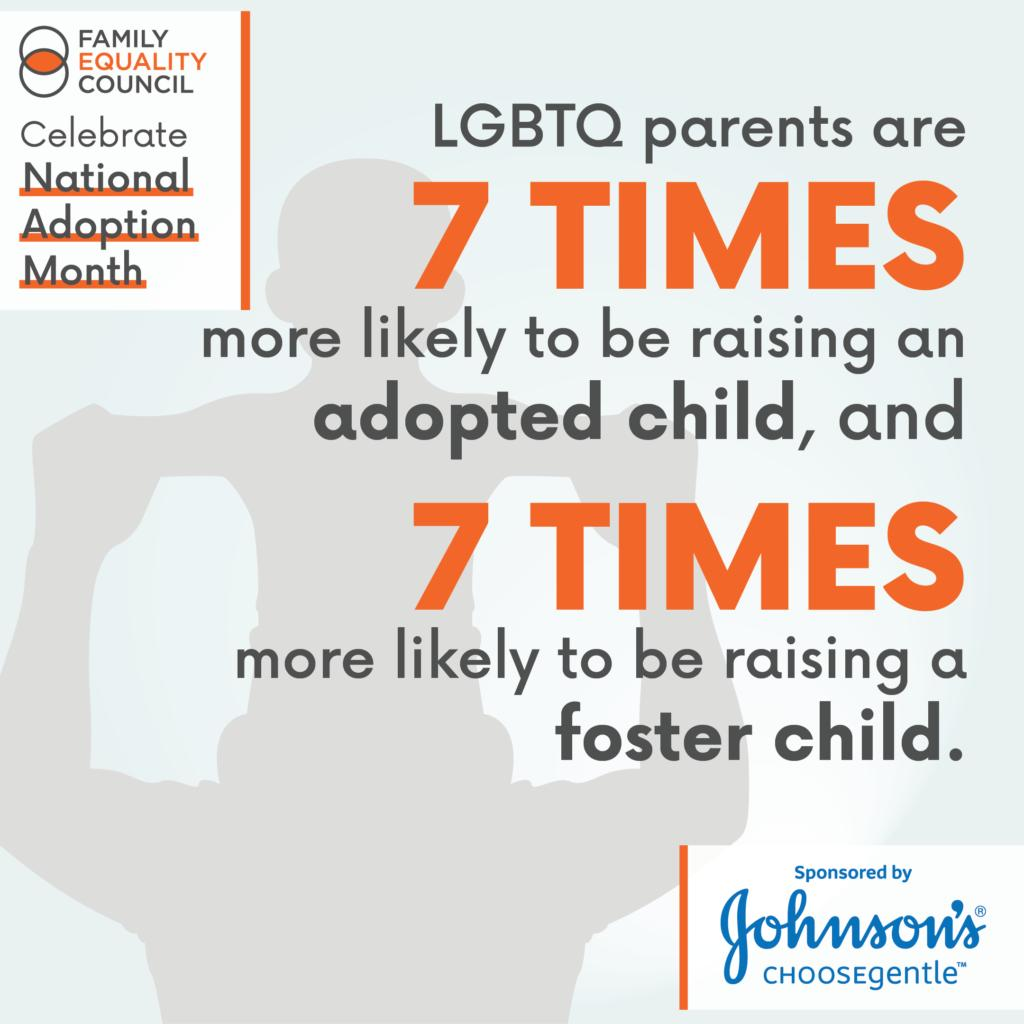Specify some key components in this picture. LGBTQ parents are more likely to raise foster children than non-LGBTQ individuals. The color of digit 7 is orange. National Adoption Month is being celebrated. 